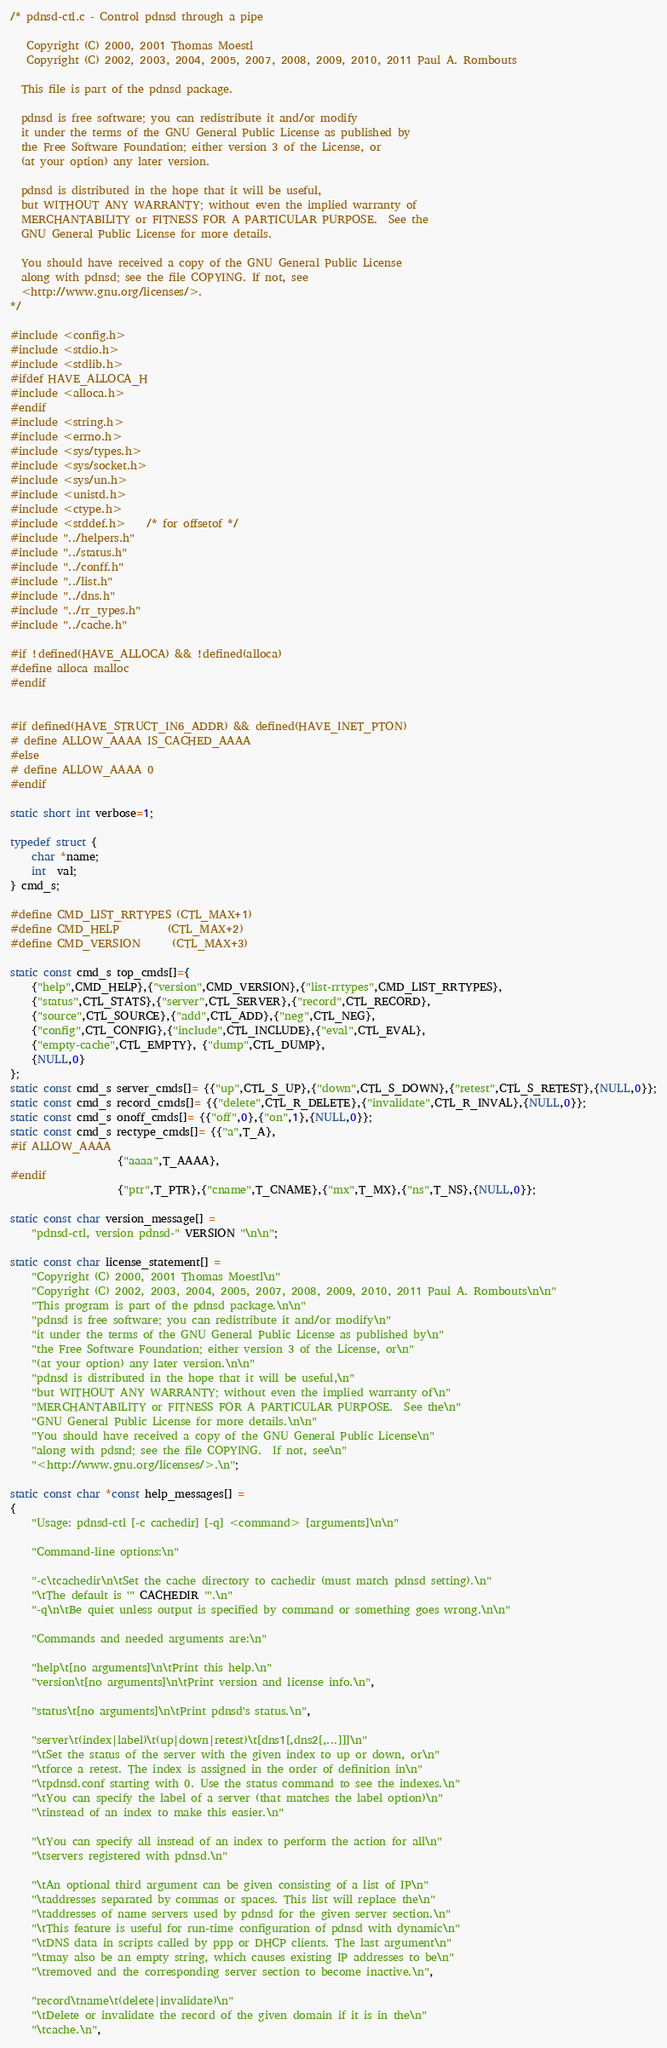Convert code to text. <code><loc_0><loc_0><loc_500><loc_500><_C_>/* pdnsd-ctl.c - Control pdnsd through a pipe

   Copyright (C) 2000, 2001 Thomas Moestl
   Copyright (C) 2002, 2003, 2004, 2005, 2007, 2008, 2009, 2010, 2011 Paul A. Rombouts

  This file is part of the pdnsd package.

  pdnsd is free software; you can redistribute it and/or modify
  it under the terms of the GNU General Public License as published by
  the Free Software Foundation; either version 3 of the License, or
  (at your option) any later version.

  pdnsd is distributed in the hope that it will be useful,
  but WITHOUT ANY WARRANTY; without even the implied warranty of
  MERCHANTABILITY or FITNESS FOR A PARTICULAR PURPOSE.  See the
  GNU General Public License for more details.

  You should have received a copy of the GNU General Public License
  along with pdnsd; see the file COPYING. If not, see
  <http://www.gnu.org/licenses/>.
*/

#include <config.h>
#include <stdio.h>
#include <stdlib.h>
#ifdef HAVE_ALLOCA_H
#include <alloca.h>
#endif
#include <string.h>
#include <errno.h>
#include <sys/types.h>
#include <sys/socket.h>
#include <sys/un.h>
#include <unistd.h>
#include <ctype.h>
#include <stddef.h>	/* for offsetof */
#include "../helpers.h"
#include "../status.h"
#include "../conff.h"
#include "../list.h"
#include "../dns.h"
#include "../rr_types.h"
#include "../cache.h"

#if !defined(HAVE_ALLOCA) && !defined(alloca)
#define alloca malloc
#endif


#if defined(HAVE_STRUCT_IN6_ADDR) && defined(HAVE_INET_PTON)
# define ALLOW_AAAA IS_CACHED_AAAA
#else
# define ALLOW_AAAA 0
#endif

static short int verbose=1;

typedef struct {
	char *name;
	int  val;
} cmd_s;

#define CMD_LIST_RRTYPES (CTL_MAX+1)
#define CMD_HELP         (CTL_MAX+2)
#define CMD_VERSION      (CTL_MAX+3)

static const cmd_s top_cmds[]={
	{"help",CMD_HELP},{"version",CMD_VERSION},{"list-rrtypes",CMD_LIST_RRTYPES},
	{"status",CTL_STATS},{"server",CTL_SERVER},{"record",CTL_RECORD},
	{"source",CTL_SOURCE},{"add",CTL_ADD},{"neg",CTL_NEG},
	{"config",CTL_CONFIG},{"include",CTL_INCLUDE},{"eval",CTL_EVAL},
	{"empty-cache",CTL_EMPTY}, {"dump",CTL_DUMP},
	{NULL,0}
};
static const cmd_s server_cmds[]= {{"up",CTL_S_UP},{"down",CTL_S_DOWN},{"retest",CTL_S_RETEST},{NULL,0}};
static const cmd_s record_cmds[]= {{"delete",CTL_R_DELETE},{"invalidate",CTL_R_INVAL},{NULL,0}};
static const cmd_s onoff_cmds[]= {{"off",0},{"on",1},{NULL,0}};
static const cmd_s rectype_cmds[]= {{"a",T_A},
#if ALLOW_AAAA
				    {"aaaa",T_AAAA},
#endif
				    {"ptr",T_PTR},{"cname",T_CNAME},{"mx",T_MX},{"ns",T_NS},{NULL,0}};

static const char version_message[] =
	"pdnsd-ctl, version pdnsd-" VERSION "\n\n";

static const char license_statement[] =
	"Copyright (C) 2000, 2001 Thomas Moestl\n"
	"Copyright (C) 2002, 2003, 2004, 2005, 2007, 2008, 2009, 2010, 2011 Paul A. Rombouts\n\n"
	"This program is part of the pdnsd package.\n\n"
	"pdnsd is free software; you can redistribute it and/or modify\n"
	"it under the terms of the GNU General Public License as published by\n"
	"the Free Software Foundation; either version 3 of the License, or\n"
	"(at your option) any later version.\n\n"
	"pdnsd is distributed in the hope that it will be useful,\n"
	"but WITHOUT ANY WARRANTY; without even the implied warranty of\n"
	"MERCHANTABILITY or FITNESS FOR A PARTICULAR PURPOSE.  See the\n"
	"GNU General Public License for more details.\n\n"
	"You should have received a copy of the GNU General Public License\n"
	"along with pdsnd; see the file COPYING.  If not, see\n"
	"<http://www.gnu.org/licenses/>.\n";

static const char *const help_messages[] =
{
	"Usage: pdnsd-ctl [-c cachedir] [-q] <command> [arguments]\n\n"

	"Command-line options:\n"

	"-c\tcachedir\n\tSet the cache directory to cachedir (must match pdnsd setting).\n"
	"\tThe default is '" CACHEDIR "'.\n"
	"-q\n\tBe quiet unless output is specified by command or something goes wrong.\n\n"

	"Commands and needed arguments are:\n"

	"help\t[no arguments]\n\tPrint this help.\n"
	"version\t[no arguments]\n\tPrint version and license info.\n",

	"status\t[no arguments]\n\tPrint pdnsd's status.\n",

	"server\t(index|label)\t(up|down|retest)\t[dns1[,dns2[,...]]]\n"
	"\tSet the status of the server with the given index to up or down, or\n"
	"\tforce a retest. The index is assigned in the order of definition in\n"
	"\tpdnsd.conf starting with 0. Use the status command to see the indexes.\n"
	"\tYou can specify the label of a server (that matches the label option)\n"
	"\tinstead of an index to make this easier.\n"

	"\tYou can specify all instead of an index to perform the action for all\n"
	"\tservers registered with pdnsd.\n"

	"\tAn optional third argument can be given consisting of a list of IP\n"
	"\taddresses separated by commas or spaces. This list will replace the\n"
	"\taddresses of name servers used by pdnsd for the given server section.\n"
	"\tThis feature is useful for run-time configuration of pdnsd with dynamic\n"
	"\tDNS data in scripts called by ppp or DHCP clients. The last argument\n"
	"\tmay also be an empty string, which causes existing IP addresses to be\n"
	"\tremoved and the corresponding server section to become inactive.\n",

	"record\tname\t(delete|invalidate)\n"
	"\tDelete or invalidate the record of the given domain if it is in the\n"
	"\tcache.\n",
</code> 